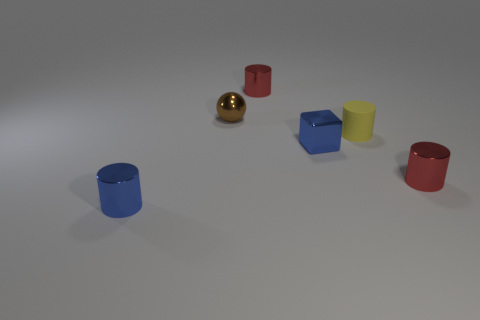What is the thing that is in front of the brown metallic thing and behind the blue block made of?
Your response must be concise. Rubber. Are there more red things that are right of the blue cube than tiny yellow objects left of the matte cylinder?
Provide a short and direct response. Yes. Are there any other yellow cylinders that have the same size as the yellow rubber cylinder?
Your answer should be compact. No. There is a red object that is on the right side of the small red shiny cylinder to the left of the tiny red object that is in front of the brown shiny ball; how big is it?
Your answer should be compact. Small. The tiny metallic cube is what color?
Your answer should be very brief. Blue. Are there more tiny red cylinders in front of the small yellow rubber object than tiny red balls?
Ensure brevity in your answer.  Yes. What number of red metal objects are behind the small cube?
Give a very brief answer. 1. What shape is the tiny object that is the same color as the cube?
Your answer should be compact. Cylinder. Are there any small cylinders in front of the small shiny cylinder on the right side of the cylinder behind the ball?
Provide a short and direct response. Yes. Is the number of small objects that are in front of the small rubber object the same as the number of spheres on the left side of the small blue shiny cylinder?
Your response must be concise. No. 